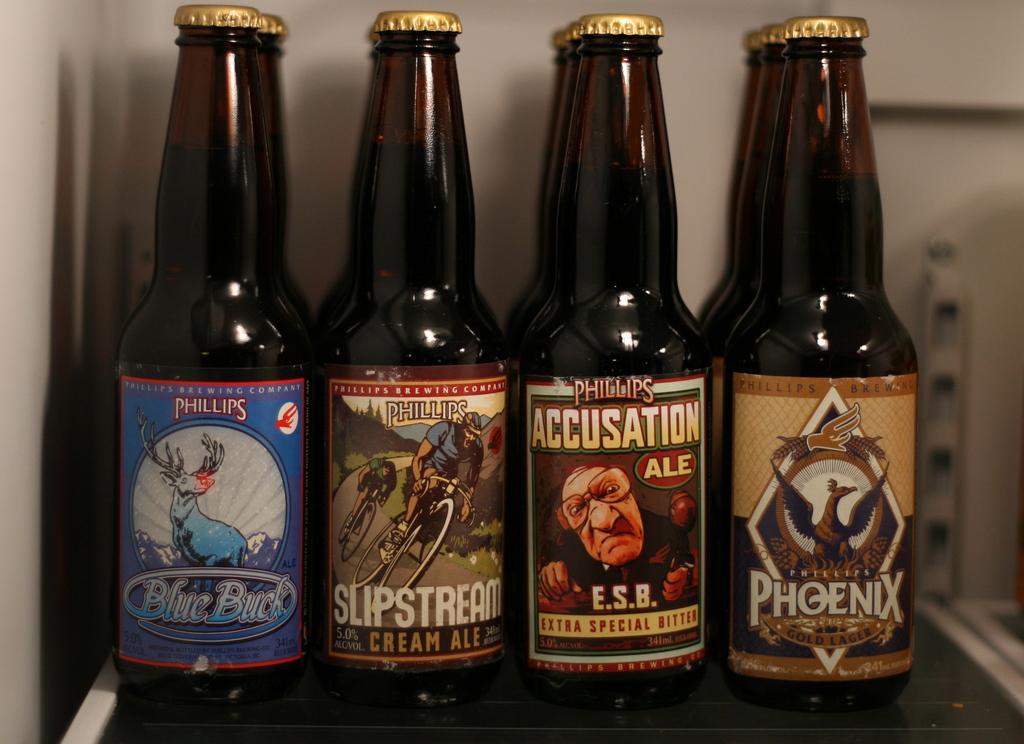Describe this image in one or two sentences. In this picture, we see four rows of brown bottle on which we see sticker with some text written on it and these bottles are placed on a table and behind that, we see a wall which is white in color. 